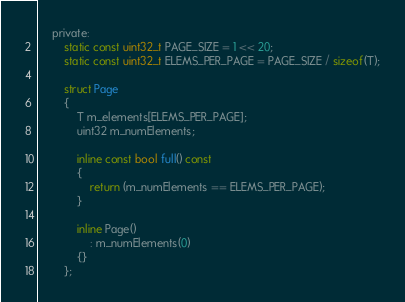Convert code to text. <code><loc_0><loc_0><loc_500><loc_500><_C_>	private:
		static const uint32_t PAGE_SIZE = 1 << 20;
		static const uint32_t ELEMS_PER_PAGE = PAGE_SIZE / sizeof(T);

		struct Page
		{
			T m_elements[ELEMS_PER_PAGE];
			uint32 m_numElements;

			inline const bool full() const
			{
				return (m_numElements == ELEMS_PER_PAGE);
			}

			inline Page()
				: m_numElements(0)
			{}
		};
</code> 